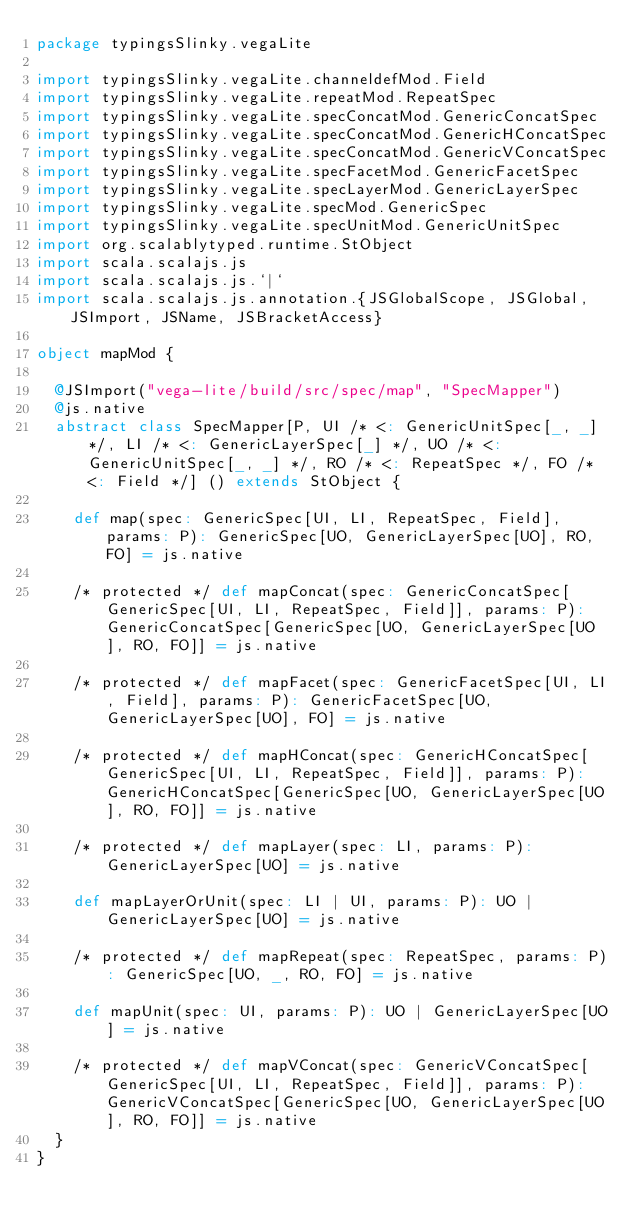Convert code to text. <code><loc_0><loc_0><loc_500><loc_500><_Scala_>package typingsSlinky.vegaLite

import typingsSlinky.vegaLite.channeldefMod.Field
import typingsSlinky.vegaLite.repeatMod.RepeatSpec
import typingsSlinky.vegaLite.specConcatMod.GenericConcatSpec
import typingsSlinky.vegaLite.specConcatMod.GenericHConcatSpec
import typingsSlinky.vegaLite.specConcatMod.GenericVConcatSpec
import typingsSlinky.vegaLite.specFacetMod.GenericFacetSpec
import typingsSlinky.vegaLite.specLayerMod.GenericLayerSpec
import typingsSlinky.vegaLite.specMod.GenericSpec
import typingsSlinky.vegaLite.specUnitMod.GenericUnitSpec
import org.scalablytyped.runtime.StObject
import scala.scalajs.js
import scala.scalajs.js.`|`
import scala.scalajs.js.annotation.{JSGlobalScope, JSGlobal, JSImport, JSName, JSBracketAccess}

object mapMod {
  
  @JSImport("vega-lite/build/src/spec/map", "SpecMapper")
  @js.native
  abstract class SpecMapper[P, UI /* <: GenericUnitSpec[_, _] */, LI /* <: GenericLayerSpec[_] */, UO /* <: GenericUnitSpec[_, _] */, RO /* <: RepeatSpec */, FO /* <: Field */] () extends StObject {
    
    def map(spec: GenericSpec[UI, LI, RepeatSpec, Field], params: P): GenericSpec[UO, GenericLayerSpec[UO], RO, FO] = js.native
    
    /* protected */ def mapConcat(spec: GenericConcatSpec[GenericSpec[UI, LI, RepeatSpec, Field]], params: P): GenericConcatSpec[GenericSpec[UO, GenericLayerSpec[UO], RO, FO]] = js.native
    
    /* protected */ def mapFacet(spec: GenericFacetSpec[UI, LI, Field], params: P): GenericFacetSpec[UO, GenericLayerSpec[UO], FO] = js.native
    
    /* protected */ def mapHConcat(spec: GenericHConcatSpec[GenericSpec[UI, LI, RepeatSpec, Field]], params: P): GenericHConcatSpec[GenericSpec[UO, GenericLayerSpec[UO], RO, FO]] = js.native
    
    /* protected */ def mapLayer(spec: LI, params: P): GenericLayerSpec[UO] = js.native
    
    def mapLayerOrUnit(spec: LI | UI, params: P): UO | GenericLayerSpec[UO] = js.native
    
    /* protected */ def mapRepeat(spec: RepeatSpec, params: P): GenericSpec[UO, _, RO, FO] = js.native
    
    def mapUnit(spec: UI, params: P): UO | GenericLayerSpec[UO] = js.native
    
    /* protected */ def mapVConcat(spec: GenericVConcatSpec[GenericSpec[UI, LI, RepeatSpec, Field]], params: P): GenericVConcatSpec[GenericSpec[UO, GenericLayerSpec[UO], RO, FO]] = js.native
  }
}
</code> 